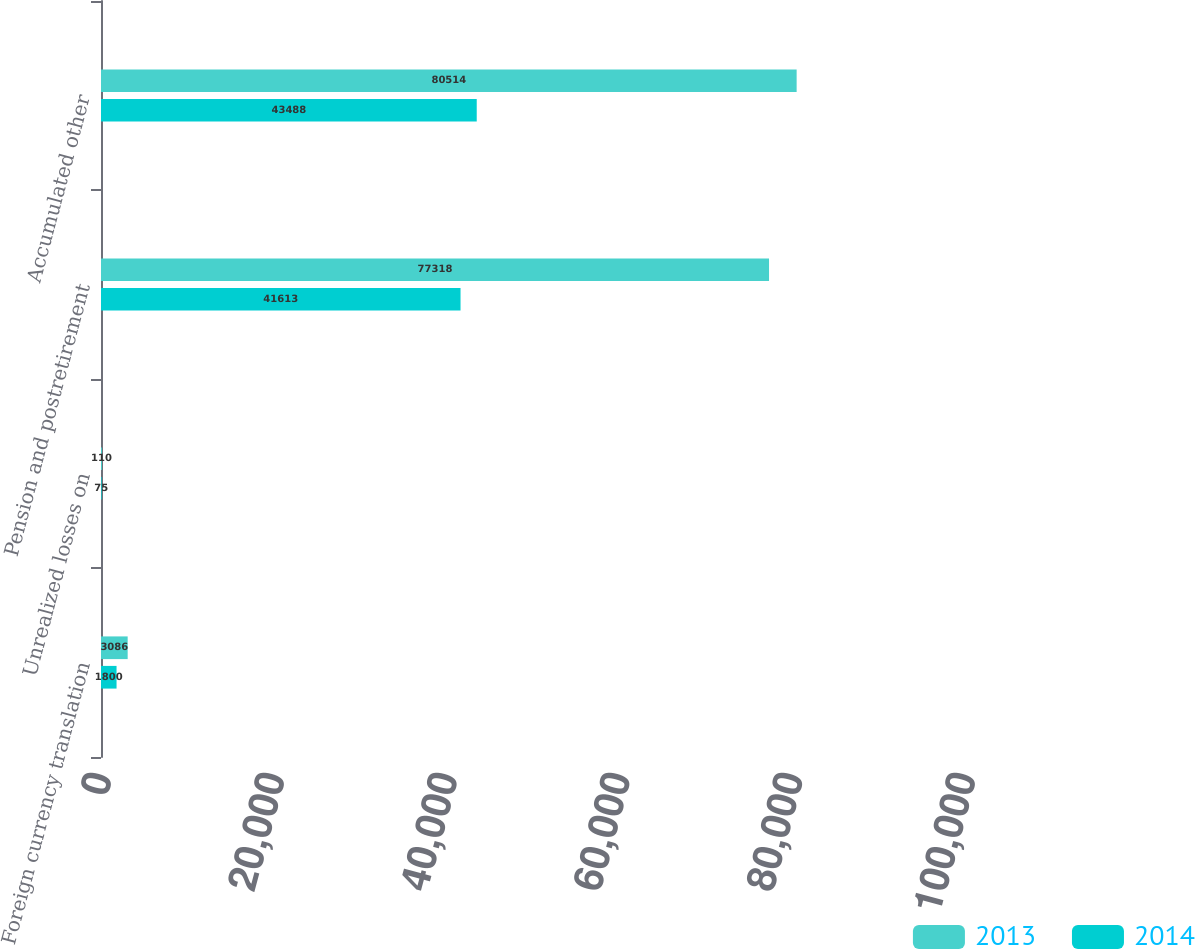<chart> <loc_0><loc_0><loc_500><loc_500><stacked_bar_chart><ecel><fcel>Foreign currency translation<fcel>Unrealized losses on<fcel>Pension and postretirement<fcel>Accumulated other<nl><fcel>2013<fcel>3086<fcel>110<fcel>77318<fcel>80514<nl><fcel>2014<fcel>1800<fcel>75<fcel>41613<fcel>43488<nl></chart> 